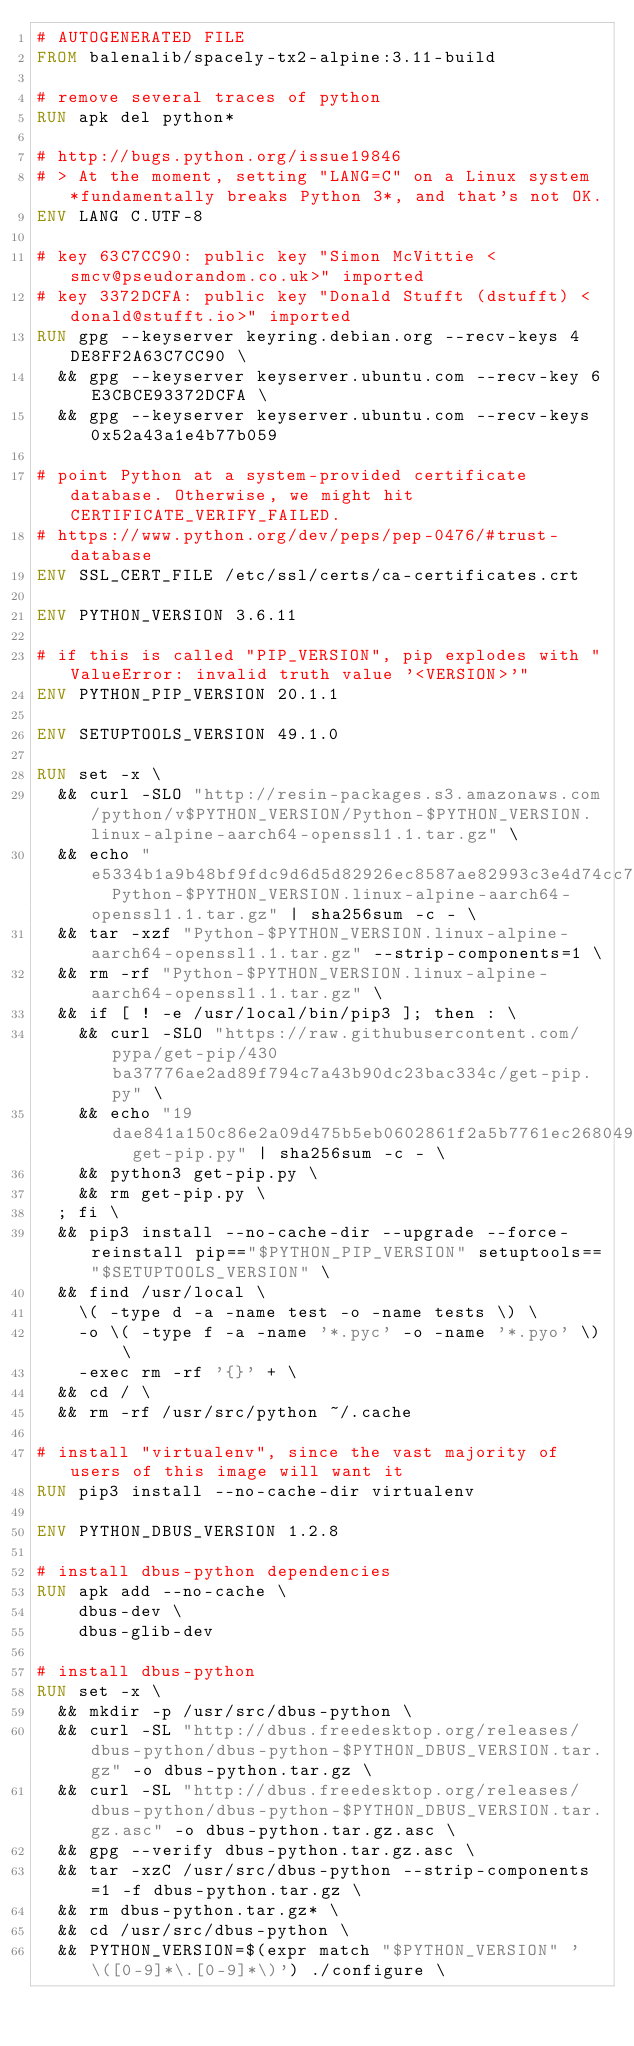<code> <loc_0><loc_0><loc_500><loc_500><_Dockerfile_># AUTOGENERATED FILE
FROM balenalib/spacely-tx2-alpine:3.11-build

# remove several traces of python
RUN apk del python*

# http://bugs.python.org/issue19846
# > At the moment, setting "LANG=C" on a Linux system *fundamentally breaks Python 3*, and that's not OK.
ENV LANG C.UTF-8

# key 63C7CC90: public key "Simon McVittie <smcv@pseudorandom.co.uk>" imported
# key 3372DCFA: public key "Donald Stufft (dstufft) <donald@stufft.io>" imported
RUN gpg --keyserver keyring.debian.org --recv-keys 4DE8FF2A63C7CC90 \
	&& gpg --keyserver keyserver.ubuntu.com --recv-key 6E3CBCE93372DCFA \
	&& gpg --keyserver keyserver.ubuntu.com --recv-keys 0x52a43a1e4b77b059

# point Python at a system-provided certificate database. Otherwise, we might hit CERTIFICATE_VERIFY_FAILED.
# https://www.python.org/dev/peps/pep-0476/#trust-database
ENV SSL_CERT_FILE /etc/ssl/certs/ca-certificates.crt

ENV PYTHON_VERSION 3.6.11

# if this is called "PIP_VERSION", pip explodes with "ValueError: invalid truth value '<VERSION>'"
ENV PYTHON_PIP_VERSION 20.1.1

ENV SETUPTOOLS_VERSION 49.1.0

RUN set -x \
	&& curl -SLO "http://resin-packages.s3.amazonaws.com/python/v$PYTHON_VERSION/Python-$PYTHON_VERSION.linux-alpine-aarch64-openssl1.1.tar.gz" \
	&& echo "e5334b1a9b48bf9fdc9d6d5d82926ec8587ae82993c3e4d74cc78306d7fadc39  Python-$PYTHON_VERSION.linux-alpine-aarch64-openssl1.1.tar.gz" | sha256sum -c - \
	&& tar -xzf "Python-$PYTHON_VERSION.linux-alpine-aarch64-openssl1.1.tar.gz" --strip-components=1 \
	&& rm -rf "Python-$PYTHON_VERSION.linux-alpine-aarch64-openssl1.1.tar.gz" \
	&& if [ ! -e /usr/local/bin/pip3 ]; then : \
		&& curl -SLO "https://raw.githubusercontent.com/pypa/get-pip/430ba37776ae2ad89f794c7a43b90dc23bac334c/get-pip.py" \
		&& echo "19dae841a150c86e2a09d475b5eb0602861f2a5b7761ec268049a662dbd2bd0c  get-pip.py" | sha256sum -c - \
		&& python3 get-pip.py \
		&& rm get-pip.py \
	; fi \
	&& pip3 install --no-cache-dir --upgrade --force-reinstall pip=="$PYTHON_PIP_VERSION" setuptools=="$SETUPTOOLS_VERSION" \
	&& find /usr/local \
		\( -type d -a -name test -o -name tests \) \
		-o \( -type f -a -name '*.pyc' -o -name '*.pyo' \) \
		-exec rm -rf '{}' + \
	&& cd / \
	&& rm -rf /usr/src/python ~/.cache

# install "virtualenv", since the vast majority of users of this image will want it
RUN pip3 install --no-cache-dir virtualenv

ENV PYTHON_DBUS_VERSION 1.2.8

# install dbus-python dependencies 
RUN apk add --no-cache \
		dbus-dev \
		dbus-glib-dev

# install dbus-python
RUN set -x \
	&& mkdir -p /usr/src/dbus-python \
	&& curl -SL "http://dbus.freedesktop.org/releases/dbus-python/dbus-python-$PYTHON_DBUS_VERSION.tar.gz" -o dbus-python.tar.gz \
	&& curl -SL "http://dbus.freedesktop.org/releases/dbus-python/dbus-python-$PYTHON_DBUS_VERSION.tar.gz.asc" -o dbus-python.tar.gz.asc \
	&& gpg --verify dbus-python.tar.gz.asc \
	&& tar -xzC /usr/src/dbus-python --strip-components=1 -f dbus-python.tar.gz \
	&& rm dbus-python.tar.gz* \
	&& cd /usr/src/dbus-python \
	&& PYTHON_VERSION=$(expr match "$PYTHON_VERSION" '\([0-9]*\.[0-9]*\)') ./configure \</code> 